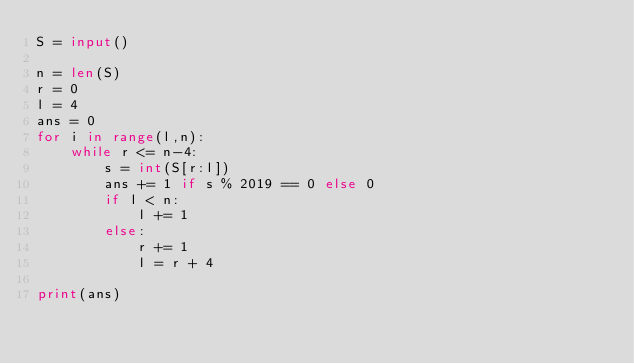<code> <loc_0><loc_0><loc_500><loc_500><_Python_>S = input()
 
n = len(S)
r = 0
l = 4
ans = 0
for i in range(l,n):
    while r <= n-4:
        s = int(S[r:l])
        ans += 1 if s % 2019 == 0 else 0
        if l < n:
            l += 1
        else:
            r += 1
            l = r + 4
            
print(ans)</code> 